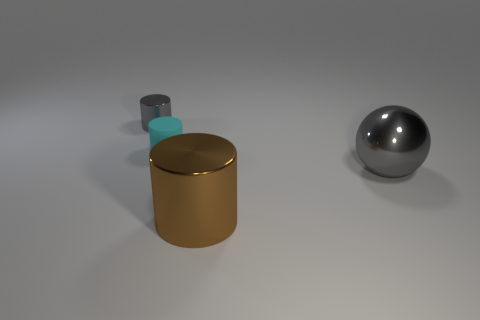Subtract all small gray cylinders. How many cylinders are left? 2 Add 2 large metal balls. How many objects exist? 6 Subtract all yellow cylinders. Subtract all yellow spheres. How many cylinders are left? 3 Subtract all rubber cylinders. Subtract all small cylinders. How many objects are left? 1 Add 4 big cylinders. How many big cylinders are left? 5 Add 1 small metal balls. How many small metal balls exist? 1 Subtract 0 purple cylinders. How many objects are left? 4 Subtract all balls. How many objects are left? 3 